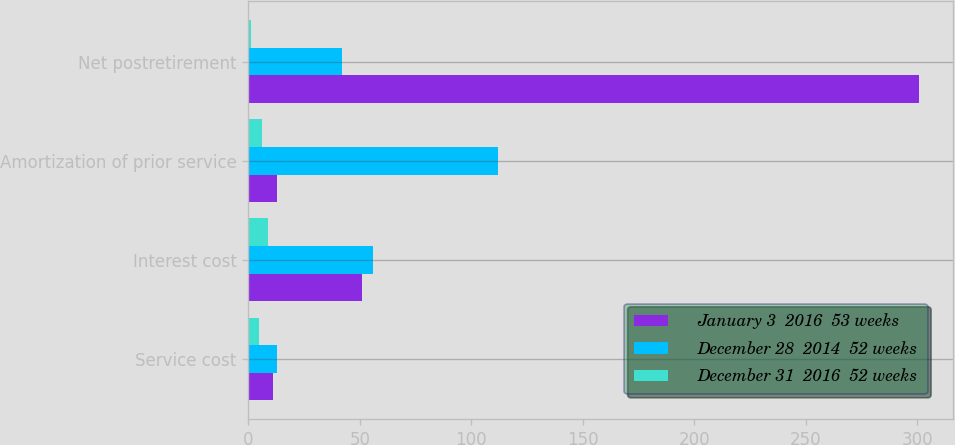Convert chart to OTSL. <chart><loc_0><loc_0><loc_500><loc_500><stacked_bar_chart><ecel><fcel>Service cost<fcel>Interest cost<fcel>Amortization of prior service<fcel>Net postretirement<nl><fcel>January 3  2016  53 weeks<fcel>11<fcel>51<fcel>13<fcel>301<nl><fcel>December 28  2014  52 weeks<fcel>13<fcel>56<fcel>112<fcel>42<nl><fcel>December 31  2016  52 weeks<fcel>5<fcel>9<fcel>6<fcel>1<nl></chart> 